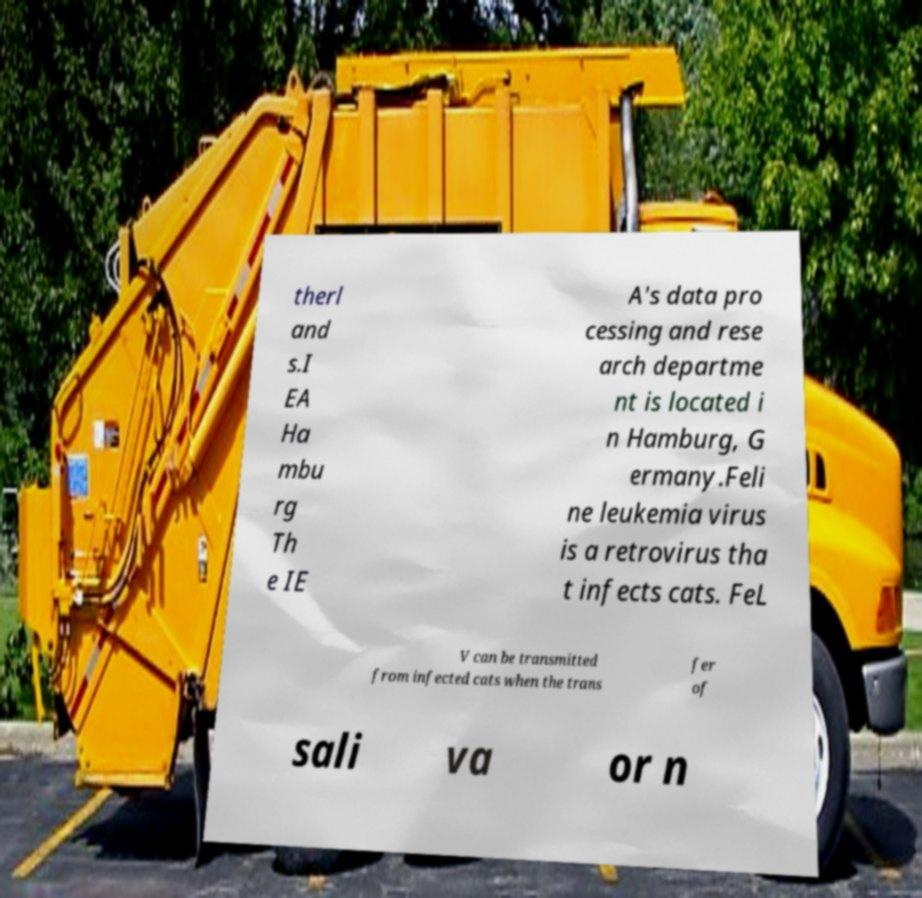For documentation purposes, I need the text within this image transcribed. Could you provide that? therl and s.I EA Ha mbu rg Th e IE A's data pro cessing and rese arch departme nt is located i n Hamburg, G ermany.Feli ne leukemia virus is a retrovirus tha t infects cats. FeL V can be transmitted from infected cats when the trans fer of sali va or n 